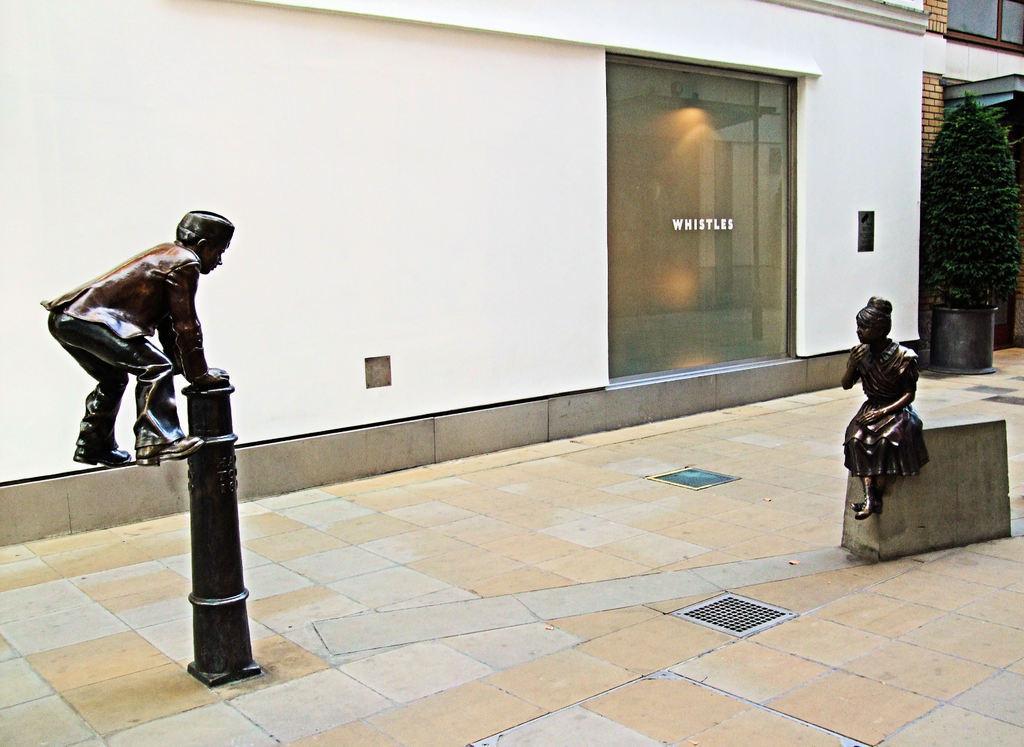Can you describe this image briefly? This is an outside view. At the bottom, I can see the ground. On the right and left side of the image I can see two statues of persons. The statue which is on the right side is sitting on a wall. In the background there is a building. In front of the building there is a plant. Here I can see a glass door to the wall. 